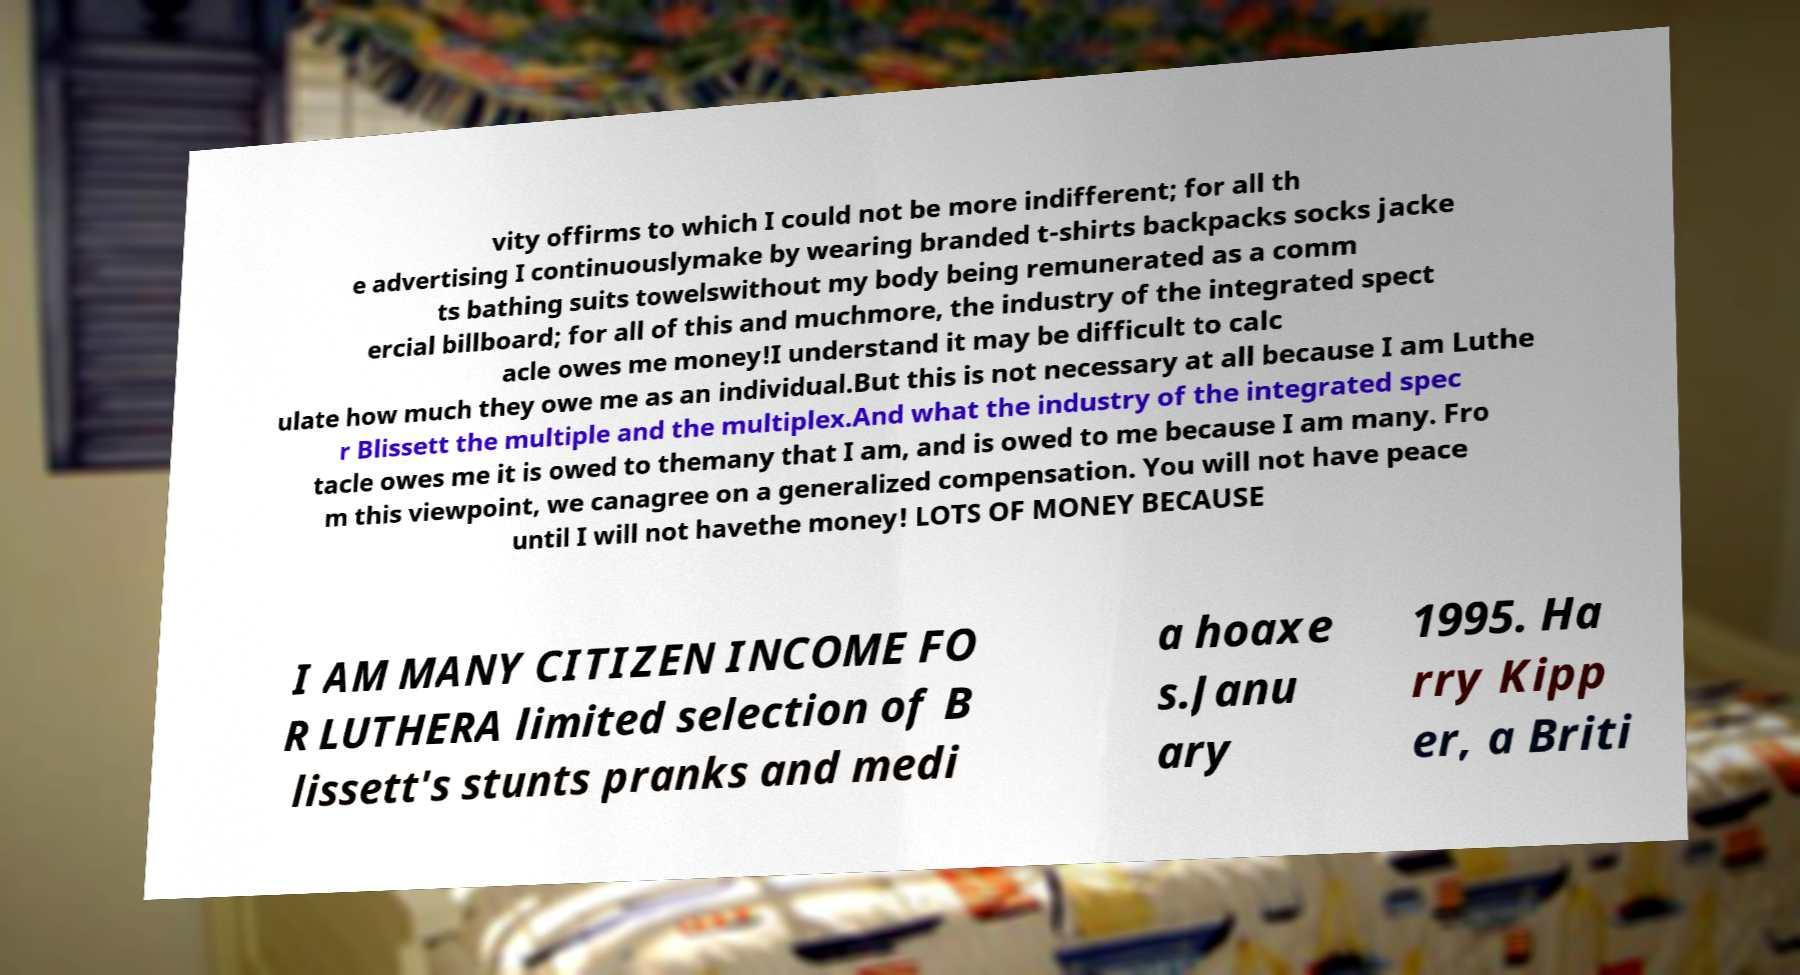Can you read and provide the text displayed in the image?This photo seems to have some interesting text. Can you extract and type it out for me? vity offirms to which I could not be more indifferent; for all th e advertising I continuouslymake by wearing branded t-shirts backpacks socks jacke ts bathing suits towelswithout my body being remunerated as a comm ercial billboard; for all of this and muchmore, the industry of the integrated spect acle owes me money!I understand it may be difficult to calc ulate how much they owe me as an individual.But this is not necessary at all because I am Luthe r Blissett the multiple and the multiplex.And what the industry of the integrated spec tacle owes me it is owed to themany that I am, and is owed to me because I am many. Fro m this viewpoint, we canagree on a generalized compensation. You will not have peace until I will not havethe money! LOTS OF MONEY BECAUSE I AM MANY CITIZEN INCOME FO R LUTHERA limited selection of B lissett's stunts pranks and medi a hoaxe s.Janu ary 1995. Ha rry Kipp er, a Briti 